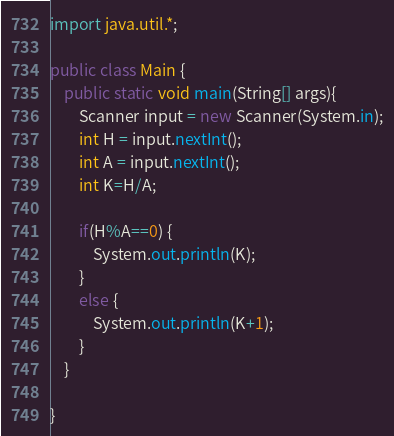Convert code to text. <code><loc_0><loc_0><loc_500><loc_500><_Java_>import java.util.*;

public class Main {
	public static void main(String[] args){
		Scanner input = new Scanner(System.in);
		int H = input.nextInt();
		int A = input.nextInt();
		int K=H/A;
		
		if(H%A==0) {
			System.out.println(K);
		}
		else {
			System.out.println(K+1);
		}
	}

}
</code> 